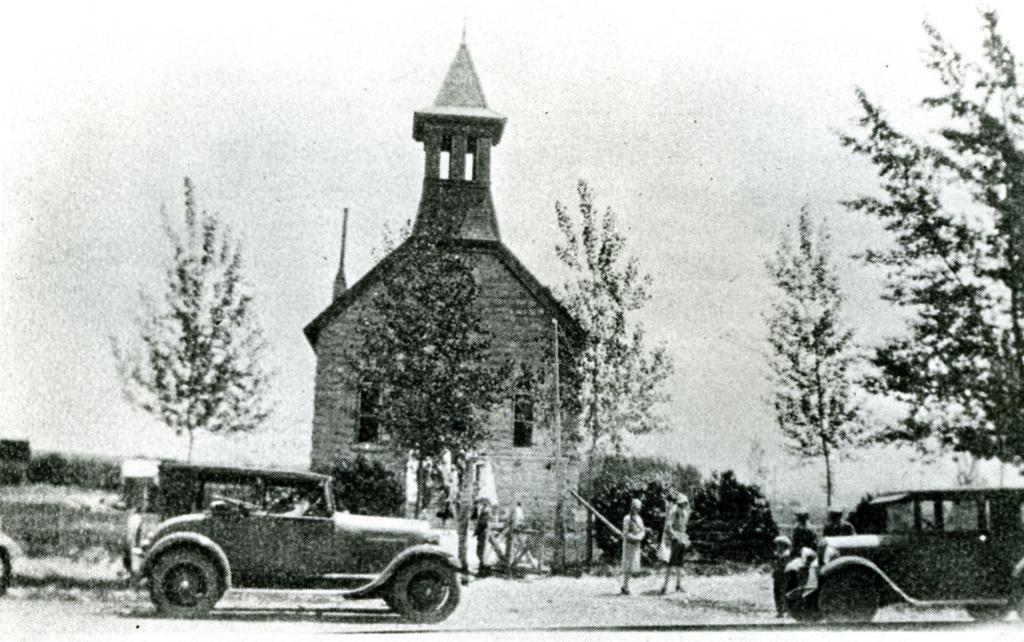What is the main subject of the image? The main subject of the image is a picture. What can be seen in the picture? There are two cars and people walking in the picture. What type of building is visible in the picture? There is a house in the picture. What is visible at the top of the picture? The sky is visible at the top of the picture. What degree of difficulty is the flag flying at in the image? There is no flag present in the image, so it is not possible to determine the degree of difficulty it might be flying at. 